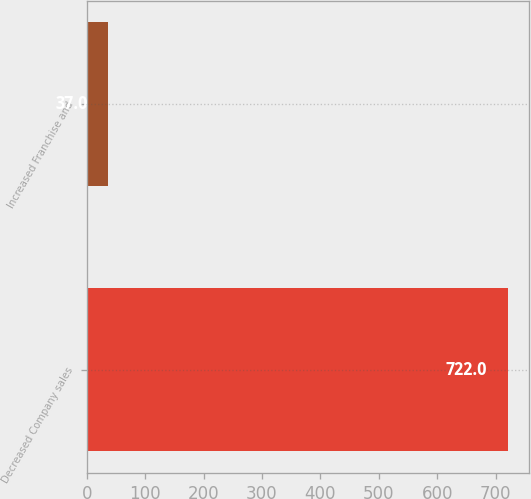Convert chart to OTSL. <chart><loc_0><loc_0><loc_500><loc_500><bar_chart><fcel>Decreased Company sales<fcel>Increased Franchise and<nl><fcel>722<fcel>37<nl></chart> 